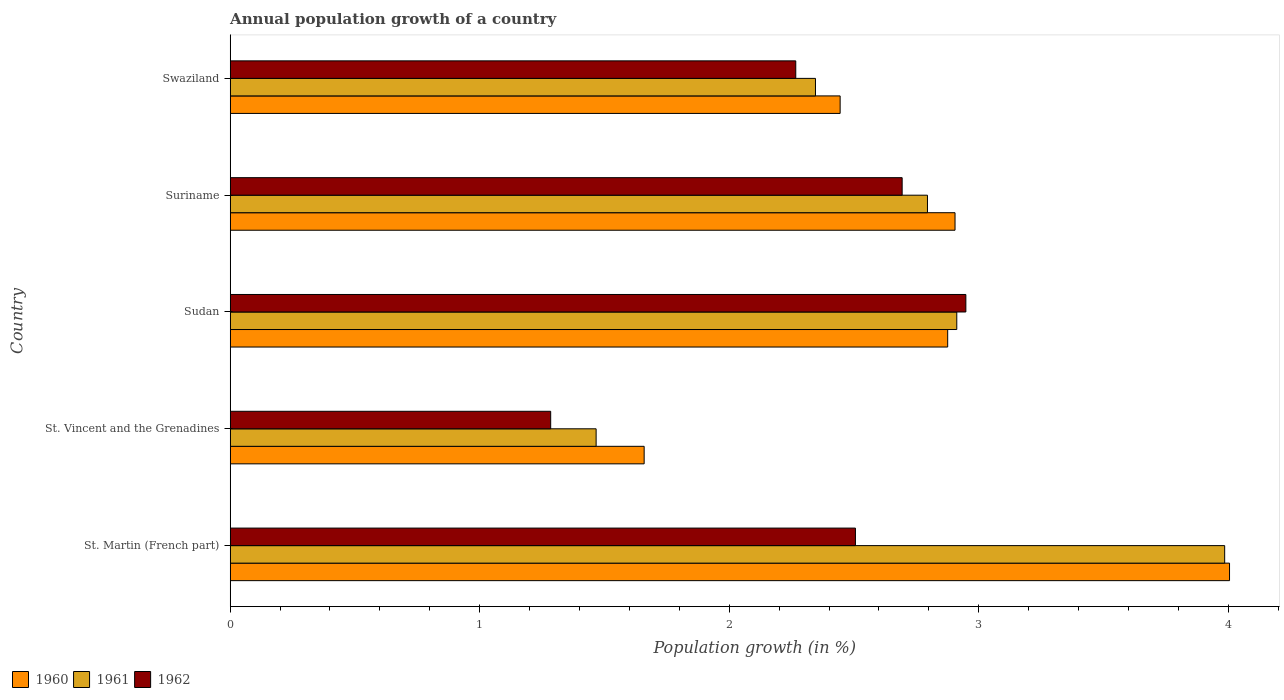How many different coloured bars are there?
Ensure brevity in your answer.  3. How many groups of bars are there?
Ensure brevity in your answer.  5. How many bars are there on the 4th tick from the bottom?
Ensure brevity in your answer.  3. What is the label of the 2nd group of bars from the top?
Ensure brevity in your answer.  Suriname. In how many cases, is the number of bars for a given country not equal to the number of legend labels?
Ensure brevity in your answer.  0. What is the annual population growth in 1961 in St. Martin (French part)?
Make the answer very short. 3.99. Across all countries, what is the maximum annual population growth in 1962?
Offer a very short reply. 2.95. Across all countries, what is the minimum annual population growth in 1961?
Offer a terse response. 1.47. In which country was the annual population growth in 1960 maximum?
Offer a very short reply. St. Martin (French part). In which country was the annual population growth in 1962 minimum?
Provide a short and direct response. St. Vincent and the Grenadines. What is the total annual population growth in 1961 in the graph?
Provide a succinct answer. 13.51. What is the difference between the annual population growth in 1960 in St. Vincent and the Grenadines and that in Swaziland?
Make the answer very short. -0.79. What is the difference between the annual population growth in 1961 in St. Martin (French part) and the annual population growth in 1960 in Swaziland?
Provide a succinct answer. 1.54. What is the average annual population growth in 1961 per country?
Give a very brief answer. 2.7. What is the difference between the annual population growth in 1960 and annual population growth in 1961 in Suriname?
Make the answer very short. 0.11. In how many countries, is the annual population growth in 1962 greater than 1.6 %?
Provide a short and direct response. 4. What is the ratio of the annual population growth in 1962 in Suriname to that in Swaziland?
Offer a very short reply. 1.19. Is the annual population growth in 1962 in St. Martin (French part) less than that in Swaziland?
Your answer should be compact. No. Is the difference between the annual population growth in 1960 in St. Vincent and the Grenadines and Sudan greater than the difference between the annual population growth in 1961 in St. Vincent and the Grenadines and Sudan?
Keep it short and to the point. Yes. What is the difference between the highest and the second highest annual population growth in 1962?
Offer a very short reply. 0.26. What is the difference between the highest and the lowest annual population growth in 1960?
Keep it short and to the point. 2.35. What does the 3rd bar from the top in Sudan represents?
Offer a very short reply. 1960. How many bars are there?
Make the answer very short. 15. How many countries are there in the graph?
Give a very brief answer. 5. What is the difference between two consecutive major ticks on the X-axis?
Give a very brief answer. 1. Does the graph contain any zero values?
Your answer should be compact. No. Does the graph contain grids?
Give a very brief answer. No. How are the legend labels stacked?
Your answer should be compact. Horizontal. What is the title of the graph?
Give a very brief answer. Annual population growth of a country. What is the label or title of the X-axis?
Your response must be concise. Population growth (in %). What is the label or title of the Y-axis?
Offer a very short reply. Country. What is the Population growth (in %) of 1960 in St. Martin (French part)?
Ensure brevity in your answer.  4.01. What is the Population growth (in %) in 1961 in St. Martin (French part)?
Your answer should be compact. 3.99. What is the Population growth (in %) in 1962 in St. Martin (French part)?
Give a very brief answer. 2.51. What is the Population growth (in %) in 1960 in St. Vincent and the Grenadines?
Your answer should be compact. 1.66. What is the Population growth (in %) of 1961 in St. Vincent and the Grenadines?
Provide a succinct answer. 1.47. What is the Population growth (in %) of 1962 in St. Vincent and the Grenadines?
Your response must be concise. 1.28. What is the Population growth (in %) in 1960 in Sudan?
Provide a short and direct response. 2.88. What is the Population growth (in %) of 1961 in Sudan?
Your answer should be compact. 2.91. What is the Population growth (in %) in 1962 in Sudan?
Your response must be concise. 2.95. What is the Population growth (in %) in 1960 in Suriname?
Your answer should be very brief. 2.91. What is the Population growth (in %) in 1961 in Suriname?
Give a very brief answer. 2.79. What is the Population growth (in %) of 1962 in Suriname?
Your answer should be very brief. 2.69. What is the Population growth (in %) in 1960 in Swaziland?
Offer a very short reply. 2.44. What is the Population growth (in %) in 1961 in Swaziland?
Your answer should be compact. 2.35. What is the Population growth (in %) of 1962 in Swaziland?
Provide a short and direct response. 2.27. Across all countries, what is the maximum Population growth (in %) of 1960?
Ensure brevity in your answer.  4.01. Across all countries, what is the maximum Population growth (in %) in 1961?
Your answer should be very brief. 3.99. Across all countries, what is the maximum Population growth (in %) of 1962?
Offer a very short reply. 2.95. Across all countries, what is the minimum Population growth (in %) in 1960?
Provide a succinct answer. 1.66. Across all countries, what is the minimum Population growth (in %) of 1961?
Keep it short and to the point. 1.47. Across all countries, what is the minimum Population growth (in %) of 1962?
Your answer should be compact. 1.28. What is the total Population growth (in %) in 1960 in the graph?
Offer a terse response. 13.89. What is the total Population growth (in %) of 1961 in the graph?
Provide a succinct answer. 13.51. What is the total Population growth (in %) of 1962 in the graph?
Offer a very short reply. 11.7. What is the difference between the Population growth (in %) of 1960 in St. Martin (French part) and that in St. Vincent and the Grenadines?
Provide a short and direct response. 2.35. What is the difference between the Population growth (in %) in 1961 in St. Martin (French part) and that in St. Vincent and the Grenadines?
Offer a terse response. 2.52. What is the difference between the Population growth (in %) of 1962 in St. Martin (French part) and that in St. Vincent and the Grenadines?
Keep it short and to the point. 1.22. What is the difference between the Population growth (in %) in 1960 in St. Martin (French part) and that in Sudan?
Give a very brief answer. 1.13. What is the difference between the Population growth (in %) of 1961 in St. Martin (French part) and that in Sudan?
Offer a very short reply. 1.07. What is the difference between the Population growth (in %) in 1962 in St. Martin (French part) and that in Sudan?
Give a very brief answer. -0.44. What is the difference between the Population growth (in %) in 1960 in St. Martin (French part) and that in Suriname?
Ensure brevity in your answer.  1.1. What is the difference between the Population growth (in %) of 1961 in St. Martin (French part) and that in Suriname?
Provide a succinct answer. 1.19. What is the difference between the Population growth (in %) of 1962 in St. Martin (French part) and that in Suriname?
Offer a terse response. -0.19. What is the difference between the Population growth (in %) in 1960 in St. Martin (French part) and that in Swaziland?
Provide a short and direct response. 1.56. What is the difference between the Population growth (in %) of 1961 in St. Martin (French part) and that in Swaziland?
Offer a very short reply. 1.64. What is the difference between the Population growth (in %) of 1962 in St. Martin (French part) and that in Swaziland?
Ensure brevity in your answer.  0.24. What is the difference between the Population growth (in %) in 1960 in St. Vincent and the Grenadines and that in Sudan?
Provide a short and direct response. -1.22. What is the difference between the Population growth (in %) of 1961 in St. Vincent and the Grenadines and that in Sudan?
Offer a very short reply. -1.45. What is the difference between the Population growth (in %) in 1962 in St. Vincent and the Grenadines and that in Sudan?
Give a very brief answer. -1.66. What is the difference between the Population growth (in %) in 1960 in St. Vincent and the Grenadines and that in Suriname?
Offer a very short reply. -1.25. What is the difference between the Population growth (in %) of 1961 in St. Vincent and the Grenadines and that in Suriname?
Your answer should be very brief. -1.33. What is the difference between the Population growth (in %) in 1962 in St. Vincent and the Grenadines and that in Suriname?
Keep it short and to the point. -1.41. What is the difference between the Population growth (in %) in 1960 in St. Vincent and the Grenadines and that in Swaziland?
Provide a short and direct response. -0.79. What is the difference between the Population growth (in %) in 1961 in St. Vincent and the Grenadines and that in Swaziland?
Your answer should be compact. -0.88. What is the difference between the Population growth (in %) in 1962 in St. Vincent and the Grenadines and that in Swaziland?
Ensure brevity in your answer.  -0.98. What is the difference between the Population growth (in %) of 1960 in Sudan and that in Suriname?
Provide a short and direct response. -0.03. What is the difference between the Population growth (in %) of 1961 in Sudan and that in Suriname?
Provide a short and direct response. 0.12. What is the difference between the Population growth (in %) of 1962 in Sudan and that in Suriname?
Provide a succinct answer. 0.26. What is the difference between the Population growth (in %) in 1960 in Sudan and that in Swaziland?
Ensure brevity in your answer.  0.43. What is the difference between the Population growth (in %) of 1961 in Sudan and that in Swaziland?
Your answer should be compact. 0.57. What is the difference between the Population growth (in %) in 1962 in Sudan and that in Swaziland?
Make the answer very short. 0.68. What is the difference between the Population growth (in %) of 1960 in Suriname and that in Swaziland?
Make the answer very short. 0.46. What is the difference between the Population growth (in %) of 1961 in Suriname and that in Swaziland?
Your answer should be compact. 0.45. What is the difference between the Population growth (in %) of 1962 in Suriname and that in Swaziland?
Offer a very short reply. 0.43. What is the difference between the Population growth (in %) of 1960 in St. Martin (French part) and the Population growth (in %) of 1961 in St. Vincent and the Grenadines?
Offer a terse response. 2.54. What is the difference between the Population growth (in %) of 1960 in St. Martin (French part) and the Population growth (in %) of 1962 in St. Vincent and the Grenadines?
Your answer should be very brief. 2.72. What is the difference between the Population growth (in %) of 1961 in St. Martin (French part) and the Population growth (in %) of 1962 in St. Vincent and the Grenadines?
Make the answer very short. 2.7. What is the difference between the Population growth (in %) of 1960 in St. Martin (French part) and the Population growth (in %) of 1961 in Sudan?
Your response must be concise. 1.09. What is the difference between the Population growth (in %) in 1960 in St. Martin (French part) and the Population growth (in %) in 1962 in Sudan?
Ensure brevity in your answer.  1.06. What is the difference between the Population growth (in %) in 1961 in St. Martin (French part) and the Population growth (in %) in 1962 in Sudan?
Provide a short and direct response. 1.04. What is the difference between the Population growth (in %) of 1960 in St. Martin (French part) and the Population growth (in %) of 1961 in Suriname?
Ensure brevity in your answer.  1.21. What is the difference between the Population growth (in %) in 1960 in St. Martin (French part) and the Population growth (in %) in 1962 in Suriname?
Keep it short and to the point. 1.31. What is the difference between the Population growth (in %) of 1961 in St. Martin (French part) and the Population growth (in %) of 1962 in Suriname?
Your answer should be very brief. 1.29. What is the difference between the Population growth (in %) of 1960 in St. Martin (French part) and the Population growth (in %) of 1961 in Swaziland?
Your response must be concise. 1.66. What is the difference between the Population growth (in %) of 1960 in St. Martin (French part) and the Population growth (in %) of 1962 in Swaziland?
Provide a succinct answer. 1.74. What is the difference between the Population growth (in %) of 1961 in St. Martin (French part) and the Population growth (in %) of 1962 in Swaziland?
Your answer should be compact. 1.72. What is the difference between the Population growth (in %) in 1960 in St. Vincent and the Grenadines and the Population growth (in %) in 1961 in Sudan?
Your answer should be compact. -1.25. What is the difference between the Population growth (in %) in 1960 in St. Vincent and the Grenadines and the Population growth (in %) in 1962 in Sudan?
Your response must be concise. -1.29. What is the difference between the Population growth (in %) in 1961 in St. Vincent and the Grenadines and the Population growth (in %) in 1962 in Sudan?
Provide a short and direct response. -1.48. What is the difference between the Population growth (in %) of 1960 in St. Vincent and the Grenadines and the Population growth (in %) of 1961 in Suriname?
Offer a very short reply. -1.14. What is the difference between the Population growth (in %) in 1960 in St. Vincent and the Grenadines and the Population growth (in %) in 1962 in Suriname?
Make the answer very short. -1.03. What is the difference between the Population growth (in %) in 1961 in St. Vincent and the Grenadines and the Population growth (in %) in 1962 in Suriname?
Offer a very short reply. -1.23. What is the difference between the Population growth (in %) in 1960 in St. Vincent and the Grenadines and the Population growth (in %) in 1961 in Swaziland?
Give a very brief answer. -0.69. What is the difference between the Population growth (in %) of 1960 in St. Vincent and the Grenadines and the Population growth (in %) of 1962 in Swaziland?
Your response must be concise. -0.61. What is the difference between the Population growth (in %) of 1961 in St. Vincent and the Grenadines and the Population growth (in %) of 1962 in Swaziland?
Make the answer very short. -0.8. What is the difference between the Population growth (in %) of 1960 in Sudan and the Population growth (in %) of 1961 in Suriname?
Give a very brief answer. 0.08. What is the difference between the Population growth (in %) of 1960 in Sudan and the Population growth (in %) of 1962 in Suriname?
Offer a terse response. 0.18. What is the difference between the Population growth (in %) of 1961 in Sudan and the Population growth (in %) of 1962 in Suriname?
Your answer should be compact. 0.22. What is the difference between the Population growth (in %) in 1960 in Sudan and the Population growth (in %) in 1961 in Swaziland?
Give a very brief answer. 0.53. What is the difference between the Population growth (in %) in 1960 in Sudan and the Population growth (in %) in 1962 in Swaziland?
Make the answer very short. 0.61. What is the difference between the Population growth (in %) in 1961 in Sudan and the Population growth (in %) in 1962 in Swaziland?
Your answer should be very brief. 0.65. What is the difference between the Population growth (in %) of 1960 in Suriname and the Population growth (in %) of 1961 in Swaziland?
Your response must be concise. 0.56. What is the difference between the Population growth (in %) of 1960 in Suriname and the Population growth (in %) of 1962 in Swaziland?
Your response must be concise. 0.64. What is the difference between the Population growth (in %) in 1961 in Suriname and the Population growth (in %) in 1962 in Swaziland?
Provide a succinct answer. 0.53. What is the average Population growth (in %) of 1960 per country?
Offer a terse response. 2.78. What is the average Population growth (in %) of 1961 per country?
Provide a short and direct response. 2.7. What is the average Population growth (in %) in 1962 per country?
Make the answer very short. 2.34. What is the difference between the Population growth (in %) of 1960 and Population growth (in %) of 1961 in St. Martin (French part)?
Offer a terse response. 0.02. What is the difference between the Population growth (in %) in 1960 and Population growth (in %) in 1962 in St. Martin (French part)?
Your answer should be very brief. 1.5. What is the difference between the Population growth (in %) in 1961 and Population growth (in %) in 1962 in St. Martin (French part)?
Offer a terse response. 1.48. What is the difference between the Population growth (in %) in 1960 and Population growth (in %) in 1961 in St. Vincent and the Grenadines?
Provide a short and direct response. 0.19. What is the difference between the Population growth (in %) in 1960 and Population growth (in %) in 1962 in St. Vincent and the Grenadines?
Provide a short and direct response. 0.37. What is the difference between the Population growth (in %) of 1961 and Population growth (in %) of 1962 in St. Vincent and the Grenadines?
Make the answer very short. 0.18. What is the difference between the Population growth (in %) in 1960 and Population growth (in %) in 1961 in Sudan?
Offer a very short reply. -0.04. What is the difference between the Population growth (in %) of 1960 and Population growth (in %) of 1962 in Sudan?
Provide a succinct answer. -0.07. What is the difference between the Population growth (in %) in 1961 and Population growth (in %) in 1962 in Sudan?
Give a very brief answer. -0.04. What is the difference between the Population growth (in %) of 1960 and Population growth (in %) of 1961 in Suriname?
Keep it short and to the point. 0.11. What is the difference between the Population growth (in %) of 1960 and Population growth (in %) of 1962 in Suriname?
Your answer should be very brief. 0.21. What is the difference between the Population growth (in %) in 1961 and Population growth (in %) in 1962 in Suriname?
Make the answer very short. 0.1. What is the difference between the Population growth (in %) in 1960 and Population growth (in %) in 1961 in Swaziland?
Give a very brief answer. 0.1. What is the difference between the Population growth (in %) of 1960 and Population growth (in %) of 1962 in Swaziland?
Offer a terse response. 0.18. What is the difference between the Population growth (in %) of 1961 and Population growth (in %) of 1962 in Swaziland?
Your answer should be very brief. 0.08. What is the ratio of the Population growth (in %) of 1960 in St. Martin (French part) to that in St. Vincent and the Grenadines?
Your answer should be compact. 2.41. What is the ratio of the Population growth (in %) in 1961 in St. Martin (French part) to that in St. Vincent and the Grenadines?
Your answer should be compact. 2.72. What is the ratio of the Population growth (in %) in 1962 in St. Martin (French part) to that in St. Vincent and the Grenadines?
Provide a succinct answer. 1.95. What is the ratio of the Population growth (in %) of 1960 in St. Martin (French part) to that in Sudan?
Make the answer very short. 1.39. What is the ratio of the Population growth (in %) in 1961 in St. Martin (French part) to that in Sudan?
Provide a succinct answer. 1.37. What is the ratio of the Population growth (in %) in 1962 in St. Martin (French part) to that in Sudan?
Ensure brevity in your answer.  0.85. What is the ratio of the Population growth (in %) in 1960 in St. Martin (French part) to that in Suriname?
Provide a short and direct response. 1.38. What is the ratio of the Population growth (in %) in 1961 in St. Martin (French part) to that in Suriname?
Offer a very short reply. 1.43. What is the ratio of the Population growth (in %) of 1962 in St. Martin (French part) to that in Suriname?
Ensure brevity in your answer.  0.93. What is the ratio of the Population growth (in %) in 1960 in St. Martin (French part) to that in Swaziland?
Keep it short and to the point. 1.64. What is the ratio of the Population growth (in %) of 1961 in St. Martin (French part) to that in Swaziland?
Give a very brief answer. 1.7. What is the ratio of the Population growth (in %) in 1962 in St. Martin (French part) to that in Swaziland?
Give a very brief answer. 1.11. What is the ratio of the Population growth (in %) in 1960 in St. Vincent and the Grenadines to that in Sudan?
Your answer should be compact. 0.58. What is the ratio of the Population growth (in %) of 1961 in St. Vincent and the Grenadines to that in Sudan?
Give a very brief answer. 0.5. What is the ratio of the Population growth (in %) in 1962 in St. Vincent and the Grenadines to that in Sudan?
Provide a succinct answer. 0.44. What is the ratio of the Population growth (in %) in 1960 in St. Vincent and the Grenadines to that in Suriname?
Offer a very short reply. 0.57. What is the ratio of the Population growth (in %) in 1961 in St. Vincent and the Grenadines to that in Suriname?
Your response must be concise. 0.52. What is the ratio of the Population growth (in %) in 1962 in St. Vincent and the Grenadines to that in Suriname?
Provide a short and direct response. 0.48. What is the ratio of the Population growth (in %) in 1960 in St. Vincent and the Grenadines to that in Swaziland?
Your answer should be compact. 0.68. What is the ratio of the Population growth (in %) in 1961 in St. Vincent and the Grenadines to that in Swaziland?
Your response must be concise. 0.63. What is the ratio of the Population growth (in %) in 1962 in St. Vincent and the Grenadines to that in Swaziland?
Offer a very short reply. 0.57. What is the ratio of the Population growth (in %) of 1961 in Sudan to that in Suriname?
Your response must be concise. 1.04. What is the ratio of the Population growth (in %) of 1962 in Sudan to that in Suriname?
Provide a succinct answer. 1.09. What is the ratio of the Population growth (in %) of 1960 in Sudan to that in Swaziland?
Provide a short and direct response. 1.18. What is the ratio of the Population growth (in %) in 1961 in Sudan to that in Swaziland?
Keep it short and to the point. 1.24. What is the ratio of the Population growth (in %) in 1962 in Sudan to that in Swaziland?
Give a very brief answer. 1.3. What is the ratio of the Population growth (in %) in 1960 in Suriname to that in Swaziland?
Offer a very short reply. 1.19. What is the ratio of the Population growth (in %) of 1961 in Suriname to that in Swaziland?
Offer a terse response. 1.19. What is the ratio of the Population growth (in %) of 1962 in Suriname to that in Swaziland?
Keep it short and to the point. 1.19. What is the difference between the highest and the second highest Population growth (in %) of 1960?
Your answer should be very brief. 1.1. What is the difference between the highest and the second highest Population growth (in %) in 1961?
Keep it short and to the point. 1.07. What is the difference between the highest and the second highest Population growth (in %) in 1962?
Offer a very short reply. 0.26. What is the difference between the highest and the lowest Population growth (in %) in 1960?
Keep it short and to the point. 2.35. What is the difference between the highest and the lowest Population growth (in %) of 1961?
Your response must be concise. 2.52. What is the difference between the highest and the lowest Population growth (in %) in 1962?
Give a very brief answer. 1.66. 